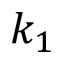<formula> <loc_0><loc_0><loc_500><loc_500>k _ { 1 }</formula> 